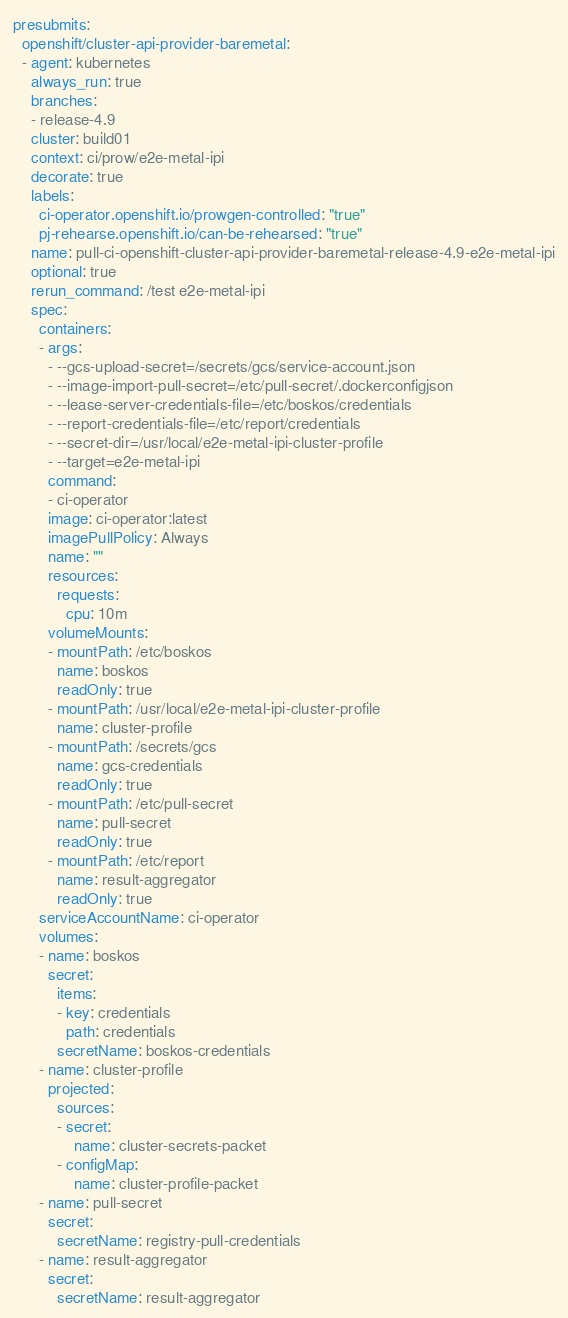<code> <loc_0><loc_0><loc_500><loc_500><_YAML_>presubmits:
  openshift/cluster-api-provider-baremetal:
  - agent: kubernetes
    always_run: true
    branches:
    - release-4.9
    cluster: build01
    context: ci/prow/e2e-metal-ipi
    decorate: true
    labels:
      ci-operator.openshift.io/prowgen-controlled: "true"
      pj-rehearse.openshift.io/can-be-rehearsed: "true"
    name: pull-ci-openshift-cluster-api-provider-baremetal-release-4.9-e2e-metal-ipi
    optional: true
    rerun_command: /test e2e-metal-ipi
    spec:
      containers:
      - args:
        - --gcs-upload-secret=/secrets/gcs/service-account.json
        - --image-import-pull-secret=/etc/pull-secret/.dockerconfigjson
        - --lease-server-credentials-file=/etc/boskos/credentials
        - --report-credentials-file=/etc/report/credentials
        - --secret-dir=/usr/local/e2e-metal-ipi-cluster-profile
        - --target=e2e-metal-ipi
        command:
        - ci-operator
        image: ci-operator:latest
        imagePullPolicy: Always
        name: ""
        resources:
          requests:
            cpu: 10m
        volumeMounts:
        - mountPath: /etc/boskos
          name: boskos
          readOnly: true
        - mountPath: /usr/local/e2e-metal-ipi-cluster-profile
          name: cluster-profile
        - mountPath: /secrets/gcs
          name: gcs-credentials
          readOnly: true
        - mountPath: /etc/pull-secret
          name: pull-secret
          readOnly: true
        - mountPath: /etc/report
          name: result-aggregator
          readOnly: true
      serviceAccountName: ci-operator
      volumes:
      - name: boskos
        secret:
          items:
          - key: credentials
            path: credentials
          secretName: boskos-credentials
      - name: cluster-profile
        projected:
          sources:
          - secret:
              name: cluster-secrets-packet
          - configMap:
              name: cluster-profile-packet
      - name: pull-secret
        secret:
          secretName: registry-pull-credentials
      - name: result-aggregator
        secret:
          secretName: result-aggregator</code> 